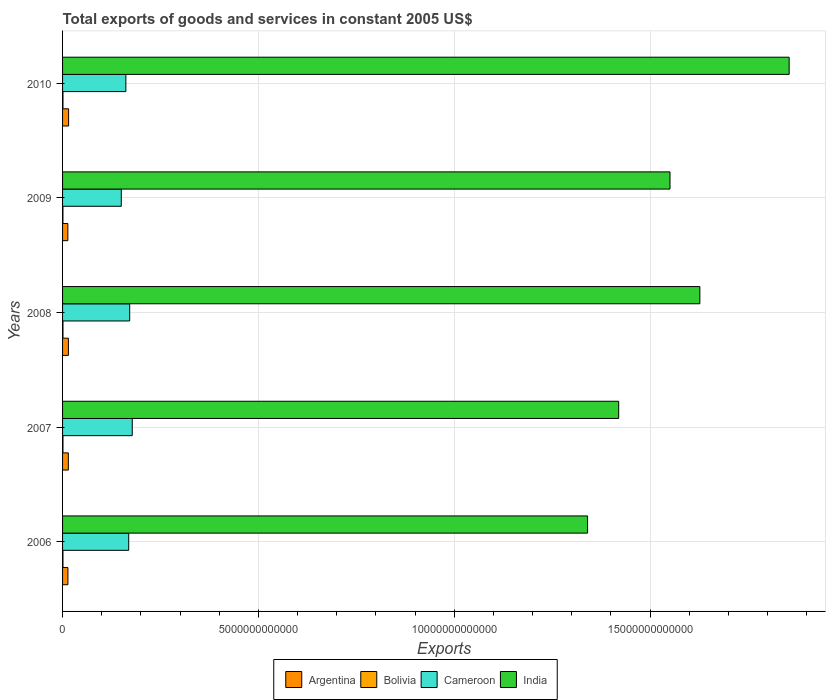How many different coloured bars are there?
Give a very brief answer. 4. How many groups of bars are there?
Offer a terse response. 5. Are the number of bars per tick equal to the number of legend labels?
Ensure brevity in your answer.  Yes. What is the label of the 5th group of bars from the top?
Ensure brevity in your answer.  2006. What is the total exports of goods and services in Bolivia in 2009?
Give a very brief answer. 9.33e+09. Across all years, what is the maximum total exports of goods and services in India?
Your answer should be very brief. 1.86e+13. Across all years, what is the minimum total exports of goods and services in Bolivia?
Make the answer very short. 9.33e+09. In which year was the total exports of goods and services in Cameroon maximum?
Ensure brevity in your answer.  2007. In which year was the total exports of goods and services in Argentina minimum?
Offer a terse response. 2009. What is the total total exports of goods and services in Argentina in the graph?
Your answer should be compact. 7.23e+11. What is the difference between the total exports of goods and services in Argentina in 2008 and that in 2009?
Your response must be concise. 1.40e+1. What is the difference between the total exports of goods and services in Argentina in 2006 and the total exports of goods and services in India in 2010?
Make the answer very short. -1.84e+13. What is the average total exports of goods and services in Cameroon per year?
Make the answer very short. 1.66e+12. In the year 2009, what is the difference between the total exports of goods and services in Bolivia and total exports of goods and services in Cameroon?
Your response must be concise. -1.49e+12. In how many years, is the total exports of goods and services in Bolivia greater than 6000000000000 US$?
Ensure brevity in your answer.  0. What is the ratio of the total exports of goods and services in Bolivia in 2006 to that in 2007?
Provide a short and direct response. 0.97. Is the total exports of goods and services in Argentina in 2007 less than that in 2008?
Your response must be concise. Yes. Is the difference between the total exports of goods and services in Bolivia in 2007 and 2010 greater than the difference between the total exports of goods and services in Cameroon in 2007 and 2010?
Offer a very short reply. No. What is the difference between the highest and the second highest total exports of goods and services in Argentina?
Provide a short and direct response. 4.93e+09. What is the difference between the highest and the lowest total exports of goods and services in India?
Keep it short and to the point. 5.15e+12. Is it the case that in every year, the sum of the total exports of goods and services in India and total exports of goods and services in Cameroon is greater than the sum of total exports of goods and services in Argentina and total exports of goods and services in Bolivia?
Offer a terse response. Yes. What does the 4th bar from the bottom in 2009 represents?
Keep it short and to the point. India. How many bars are there?
Offer a very short reply. 20. Are all the bars in the graph horizontal?
Ensure brevity in your answer.  Yes. What is the difference between two consecutive major ticks on the X-axis?
Your answer should be compact. 5.00e+12. Are the values on the major ticks of X-axis written in scientific E-notation?
Give a very brief answer. No. Does the graph contain any zero values?
Give a very brief answer. No. Does the graph contain grids?
Make the answer very short. Yes. Where does the legend appear in the graph?
Offer a very short reply. Bottom center. What is the title of the graph?
Your answer should be compact. Total exports of goods and services in constant 2005 US$. What is the label or title of the X-axis?
Your response must be concise. Exports. What is the Exports of Argentina in 2006?
Provide a succinct answer. 1.37e+11. What is the Exports of Bolivia in 2006?
Your answer should be compact. 9.92e+09. What is the Exports in Cameroon in 2006?
Offer a very short reply. 1.69e+12. What is the Exports of India in 2006?
Make the answer very short. 1.34e+13. What is the Exports in Argentina in 2007?
Offer a terse response. 1.48e+11. What is the Exports of Bolivia in 2007?
Make the answer very short. 1.02e+1. What is the Exports of Cameroon in 2007?
Keep it short and to the point. 1.78e+12. What is the Exports of India in 2007?
Provide a short and direct response. 1.42e+13. What is the Exports in Argentina in 2008?
Give a very brief answer. 1.49e+11. What is the Exports in Bolivia in 2008?
Provide a succinct answer. 1.05e+1. What is the Exports of Cameroon in 2008?
Your answer should be compact. 1.71e+12. What is the Exports of India in 2008?
Provide a succinct answer. 1.63e+13. What is the Exports of Argentina in 2009?
Make the answer very short. 1.35e+11. What is the Exports of Bolivia in 2009?
Ensure brevity in your answer.  9.33e+09. What is the Exports in Cameroon in 2009?
Keep it short and to the point. 1.50e+12. What is the Exports in India in 2009?
Provide a short and direct response. 1.55e+13. What is the Exports in Argentina in 2010?
Offer a very short reply. 1.54e+11. What is the Exports in Bolivia in 2010?
Keep it short and to the point. 1.02e+1. What is the Exports in Cameroon in 2010?
Your response must be concise. 1.62e+12. What is the Exports in India in 2010?
Give a very brief answer. 1.86e+13. Across all years, what is the maximum Exports of Argentina?
Make the answer very short. 1.54e+11. Across all years, what is the maximum Exports in Bolivia?
Keep it short and to the point. 1.05e+1. Across all years, what is the maximum Exports in Cameroon?
Offer a very short reply. 1.78e+12. Across all years, what is the maximum Exports of India?
Provide a short and direct response. 1.86e+13. Across all years, what is the minimum Exports of Argentina?
Make the answer very short. 1.35e+11. Across all years, what is the minimum Exports of Bolivia?
Make the answer very short. 9.33e+09. Across all years, what is the minimum Exports of Cameroon?
Keep it short and to the point. 1.50e+12. Across all years, what is the minimum Exports in India?
Provide a short and direct response. 1.34e+13. What is the total Exports of Argentina in the graph?
Offer a terse response. 7.23e+11. What is the total Exports of Bolivia in the graph?
Keep it short and to the point. 5.02e+1. What is the total Exports of Cameroon in the graph?
Provide a succinct answer. 8.30e+12. What is the total Exports of India in the graph?
Make the answer very short. 7.79e+13. What is the difference between the Exports in Argentina in 2006 and that in 2007?
Ensure brevity in your answer.  -1.08e+1. What is the difference between the Exports of Bolivia in 2006 and that in 2007?
Keep it short and to the point. -3.07e+08. What is the difference between the Exports of Cameroon in 2006 and that in 2007?
Provide a short and direct response. -9.02e+1. What is the difference between the Exports of India in 2006 and that in 2007?
Offer a very short reply. -7.94e+11. What is the difference between the Exports in Argentina in 2006 and that in 2008?
Offer a very short reply. -1.24e+1. What is the difference between the Exports of Bolivia in 2006 and that in 2008?
Provide a short and direct response. -5.29e+08. What is the difference between the Exports of Cameroon in 2006 and that in 2008?
Give a very brief answer. -2.45e+1. What is the difference between the Exports in India in 2006 and that in 2008?
Your response must be concise. -2.87e+12. What is the difference between the Exports in Argentina in 2006 and that in 2009?
Offer a terse response. 1.64e+09. What is the difference between the Exports of Bolivia in 2006 and that in 2009?
Your response must be concise. 5.95e+08. What is the difference between the Exports of Cameroon in 2006 and that in 2009?
Ensure brevity in your answer.  1.90e+11. What is the difference between the Exports of India in 2006 and that in 2009?
Offer a terse response. -2.10e+12. What is the difference between the Exports of Argentina in 2006 and that in 2010?
Make the answer very short. -1.73e+1. What is the difference between the Exports of Bolivia in 2006 and that in 2010?
Your answer should be very brief. -3.24e+08. What is the difference between the Exports of Cameroon in 2006 and that in 2010?
Your response must be concise. 7.30e+1. What is the difference between the Exports in India in 2006 and that in 2010?
Your answer should be compact. -5.15e+12. What is the difference between the Exports in Argentina in 2007 and that in 2008?
Make the answer very short. -1.61e+09. What is the difference between the Exports in Bolivia in 2007 and that in 2008?
Make the answer very short. -2.22e+08. What is the difference between the Exports of Cameroon in 2007 and that in 2008?
Ensure brevity in your answer.  6.56e+1. What is the difference between the Exports of India in 2007 and that in 2008?
Provide a short and direct response. -2.07e+12. What is the difference between the Exports of Argentina in 2007 and that in 2009?
Ensure brevity in your answer.  1.24e+1. What is the difference between the Exports of Bolivia in 2007 and that in 2009?
Give a very brief answer. 9.02e+08. What is the difference between the Exports of Cameroon in 2007 and that in 2009?
Your response must be concise. 2.80e+11. What is the difference between the Exports of India in 2007 and that in 2009?
Your response must be concise. -1.31e+12. What is the difference between the Exports in Argentina in 2007 and that in 2010?
Ensure brevity in your answer.  -6.54e+09. What is the difference between the Exports in Bolivia in 2007 and that in 2010?
Provide a succinct answer. -1.73e+07. What is the difference between the Exports of Cameroon in 2007 and that in 2010?
Ensure brevity in your answer.  1.63e+11. What is the difference between the Exports of India in 2007 and that in 2010?
Provide a short and direct response. -4.35e+12. What is the difference between the Exports of Argentina in 2008 and that in 2009?
Give a very brief answer. 1.40e+1. What is the difference between the Exports of Bolivia in 2008 and that in 2009?
Your answer should be compact. 1.12e+09. What is the difference between the Exports in Cameroon in 2008 and that in 2009?
Your answer should be compact. 2.14e+11. What is the difference between the Exports in India in 2008 and that in 2009?
Your answer should be very brief. 7.62e+11. What is the difference between the Exports of Argentina in 2008 and that in 2010?
Give a very brief answer. -4.93e+09. What is the difference between the Exports of Bolivia in 2008 and that in 2010?
Your answer should be compact. 2.05e+08. What is the difference between the Exports in Cameroon in 2008 and that in 2010?
Your response must be concise. 9.75e+1. What is the difference between the Exports in India in 2008 and that in 2010?
Your answer should be very brief. -2.28e+12. What is the difference between the Exports in Argentina in 2009 and that in 2010?
Provide a short and direct response. -1.89e+1. What is the difference between the Exports of Bolivia in 2009 and that in 2010?
Ensure brevity in your answer.  -9.19e+08. What is the difference between the Exports of Cameroon in 2009 and that in 2010?
Make the answer very short. -1.17e+11. What is the difference between the Exports of India in 2009 and that in 2010?
Give a very brief answer. -3.04e+12. What is the difference between the Exports of Argentina in 2006 and the Exports of Bolivia in 2007?
Your answer should be compact. 1.27e+11. What is the difference between the Exports in Argentina in 2006 and the Exports in Cameroon in 2007?
Provide a succinct answer. -1.64e+12. What is the difference between the Exports in Argentina in 2006 and the Exports in India in 2007?
Provide a short and direct response. -1.41e+13. What is the difference between the Exports of Bolivia in 2006 and the Exports of Cameroon in 2007?
Give a very brief answer. -1.77e+12. What is the difference between the Exports in Bolivia in 2006 and the Exports in India in 2007?
Give a very brief answer. -1.42e+13. What is the difference between the Exports of Cameroon in 2006 and the Exports of India in 2007?
Offer a very short reply. -1.25e+13. What is the difference between the Exports in Argentina in 2006 and the Exports in Bolivia in 2008?
Provide a short and direct response. 1.26e+11. What is the difference between the Exports in Argentina in 2006 and the Exports in Cameroon in 2008?
Offer a very short reply. -1.58e+12. What is the difference between the Exports in Argentina in 2006 and the Exports in India in 2008?
Offer a terse response. -1.61e+13. What is the difference between the Exports in Bolivia in 2006 and the Exports in Cameroon in 2008?
Ensure brevity in your answer.  -1.70e+12. What is the difference between the Exports of Bolivia in 2006 and the Exports of India in 2008?
Your response must be concise. -1.63e+13. What is the difference between the Exports in Cameroon in 2006 and the Exports in India in 2008?
Provide a succinct answer. -1.46e+13. What is the difference between the Exports in Argentina in 2006 and the Exports in Bolivia in 2009?
Ensure brevity in your answer.  1.27e+11. What is the difference between the Exports of Argentina in 2006 and the Exports of Cameroon in 2009?
Your answer should be compact. -1.36e+12. What is the difference between the Exports of Argentina in 2006 and the Exports of India in 2009?
Your answer should be very brief. -1.54e+13. What is the difference between the Exports in Bolivia in 2006 and the Exports in Cameroon in 2009?
Offer a very short reply. -1.49e+12. What is the difference between the Exports of Bolivia in 2006 and the Exports of India in 2009?
Offer a terse response. -1.55e+13. What is the difference between the Exports of Cameroon in 2006 and the Exports of India in 2009?
Make the answer very short. -1.38e+13. What is the difference between the Exports of Argentina in 2006 and the Exports of Bolivia in 2010?
Make the answer very short. 1.27e+11. What is the difference between the Exports in Argentina in 2006 and the Exports in Cameroon in 2010?
Keep it short and to the point. -1.48e+12. What is the difference between the Exports of Argentina in 2006 and the Exports of India in 2010?
Your answer should be very brief. -1.84e+13. What is the difference between the Exports in Bolivia in 2006 and the Exports in Cameroon in 2010?
Ensure brevity in your answer.  -1.61e+12. What is the difference between the Exports in Bolivia in 2006 and the Exports in India in 2010?
Provide a succinct answer. -1.85e+13. What is the difference between the Exports in Cameroon in 2006 and the Exports in India in 2010?
Keep it short and to the point. -1.69e+13. What is the difference between the Exports in Argentina in 2007 and the Exports in Bolivia in 2008?
Offer a very short reply. 1.37e+11. What is the difference between the Exports of Argentina in 2007 and the Exports of Cameroon in 2008?
Provide a short and direct response. -1.57e+12. What is the difference between the Exports of Argentina in 2007 and the Exports of India in 2008?
Make the answer very short. -1.61e+13. What is the difference between the Exports of Bolivia in 2007 and the Exports of Cameroon in 2008?
Ensure brevity in your answer.  -1.70e+12. What is the difference between the Exports of Bolivia in 2007 and the Exports of India in 2008?
Offer a very short reply. -1.63e+13. What is the difference between the Exports of Cameroon in 2007 and the Exports of India in 2008?
Keep it short and to the point. -1.45e+13. What is the difference between the Exports in Argentina in 2007 and the Exports in Bolivia in 2009?
Provide a succinct answer. 1.38e+11. What is the difference between the Exports of Argentina in 2007 and the Exports of Cameroon in 2009?
Ensure brevity in your answer.  -1.35e+12. What is the difference between the Exports in Argentina in 2007 and the Exports in India in 2009?
Your answer should be very brief. -1.54e+13. What is the difference between the Exports in Bolivia in 2007 and the Exports in Cameroon in 2009?
Your response must be concise. -1.49e+12. What is the difference between the Exports of Bolivia in 2007 and the Exports of India in 2009?
Ensure brevity in your answer.  -1.55e+13. What is the difference between the Exports in Cameroon in 2007 and the Exports in India in 2009?
Offer a terse response. -1.37e+13. What is the difference between the Exports in Argentina in 2007 and the Exports in Bolivia in 2010?
Your response must be concise. 1.37e+11. What is the difference between the Exports in Argentina in 2007 and the Exports in Cameroon in 2010?
Keep it short and to the point. -1.47e+12. What is the difference between the Exports of Argentina in 2007 and the Exports of India in 2010?
Your answer should be compact. -1.84e+13. What is the difference between the Exports of Bolivia in 2007 and the Exports of Cameroon in 2010?
Offer a very short reply. -1.61e+12. What is the difference between the Exports in Bolivia in 2007 and the Exports in India in 2010?
Your answer should be compact. -1.85e+13. What is the difference between the Exports in Cameroon in 2007 and the Exports in India in 2010?
Provide a succinct answer. -1.68e+13. What is the difference between the Exports of Argentina in 2008 and the Exports of Bolivia in 2009?
Make the answer very short. 1.40e+11. What is the difference between the Exports in Argentina in 2008 and the Exports in Cameroon in 2009?
Offer a very short reply. -1.35e+12. What is the difference between the Exports in Argentina in 2008 and the Exports in India in 2009?
Ensure brevity in your answer.  -1.54e+13. What is the difference between the Exports of Bolivia in 2008 and the Exports of Cameroon in 2009?
Your response must be concise. -1.49e+12. What is the difference between the Exports in Bolivia in 2008 and the Exports in India in 2009?
Provide a succinct answer. -1.55e+13. What is the difference between the Exports in Cameroon in 2008 and the Exports in India in 2009?
Your response must be concise. -1.38e+13. What is the difference between the Exports in Argentina in 2008 and the Exports in Bolivia in 2010?
Provide a short and direct response. 1.39e+11. What is the difference between the Exports in Argentina in 2008 and the Exports in Cameroon in 2010?
Your response must be concise. -1.47e+12. What is the difference between the Exports in Argentina in 2008 and the Exports in India in 2010?
Your answer should be very brief. -1.84e+13. What is the difference between the Exports in Bolivia in 2008 and the Exports in Cameroon in 2010?
Offer a very short reply. -1.61e+12. What is the difference between the Exports of Bolivia in 2008 and the Exports of India in 2010?
Offer a terse response. -1.85e+13. What is the difference between the Exports of Cameroon in 2008 and the Exports of India in 2010?
Ensure brevity in your answer.  -1.68e+13. What is the difference between the Exports in Argentina in 2009 and the Exports in Bolivia in 2010?
Keep it short and to the point. 1.25e+11. What is the difference between the Exports in Argentina in 2009 and the Exports in Cameroon in 2010?
Ensure brevity in your answer.  -1.48e+12. What is the difference between the Exports of Argentina in 2009 and the Exports of India in 2010?
Offer a terse response. -1.84e+13. What is the difference between the Exports in Bolivia in 2009 and the Exports in Cameroon in 2010?
Offer a very short reply. -1.61e+12. What is the difference between the Exports of Bolivia in 2009 and the Exports of India in 2010?
Give a very brief answer. -1.85e+13. What is the difference between the Exports of Cameroon in 2009 and the Exports of India in 2010?
Give a very brief answer. -1.71e+13. What is the average Exports of Argentina per year?
Provide a succinct answer. 1.45e+11. What is the average Exports in Bolivia per year?
Your answer should be very brief. 1.00e+1. What is the average Exports of Cameroon per year?
Keep it short and to the point. 1.66e+12. What is the average Exports in India per year?
Your answer should be compact. 1.56e+13. In the year 2006, what is the difference between the Exports of Argentina and Exports of Bolivia?
Your response must be concise. 1.27e+11. In the year 2006, what is the difference between the Exports in Argentina and Exports in Cameroon?
Ensure brevity in your answer.  -1.55e+12. In the year 2006, what is the difference between the Exports of Argentina and Exports of India?
Provide a short and direct response. -1.33e+13. In the year 2006, what is the difference between the Exports in Bolivia and Exports in Cameroon?
Your response must be concise. -1.68e+12. In the year 2006, what is the difference between the Exports of Bolivia and Exports of India?
Give a very brief answer. -1.34e+13. In the year 2006, what is the difference between the Exports of Cameroon and Exports of India?
Provide a short and direct response. -1.17e+13. In the year 2007, what is the difference between the Exports in Argentina and Exports in Bolivia?
Offer a very short reply. 1.37e+11. In the year 2007, what is the difference between the Exports of Argentina and Exports of Cameroon?
Your response must be concise. -1.63e+12. In the year 2007, what is the difference between the Exports in Argentina and Exports in India?
Keep it short and to the point. -1.41e+13. In the year 2007, what is the difference between the Exports of Bolivia and Exports of Cameroon?
Provide a succinct answer. -1.77e+12. In the year 2007, what is the difference between the Exports in Bolivia and Exports in India?
Make the answer very short. -1.42e+13. In the year 2007, what is the difference between the Exports in Cameroon and Exports in India?
Offer a terse response. -1.24e+13. In the year 2008, what is the difference between the Exports in Argentina and Exports in Bolivia?
Your response must be concise. 1.39e+11. In the year 2008, what is the difference between the Exports of Argentina and Exports of Cameroon?
Make the answer very short. -1.56e+12. In the year 2008, what is the difference between the Exports in Argentina and Exports in India?
Make the answer very short. -1.61e+13. In the year 2008, what is the difference between the Exports in Bolivia and Exports in Cameroon?
Ensure brevity in your answer.  -1.70e+12. In the year 2008, what is the difference between the Exports of Bolivia and Exports of India?
Keep it short and to the point. -1.63e+13. In the year 2008, what is the difference between the Exports in Cameroon and Exports in India?
Offer a very short reply. -1.46e+13. In the year 2009, what is the difference between the Exports of Argentina and Exports of Bolivia?
Offer a terse response. 1.26e+11. In the year 2009, what is the difference between the Exports in Argentina and Exports in Cameroon?
Offer a terse response. -1.36e+12. In the year 2009, what is the difference between the Exports of Argentina and Exports of India?
Provide a succinct answer. -1.54e+13. In the year 2009, what is the difference between the Exports of Bolivia and Exports of Cameroon?
Make the answer very short. -1.49e+12. In the year 2009, what is the difference between the Exports in Bolivia and Exports in India?
Offer a terse response. -1.55e+13. In the year 2009, what is the difference between the Exports in Cameroon and Exports in India?
Ensure brevity in your answer.  -1.40e+13. In the year 2010, what is the difference between the Exports of Argentina and Exports of Bolivia?
Provide a short and direct response. 1.44e+11. In the year 2010, what is the difference between the Exports of Argentina and Exports of Cameroon?
Provide a short and direct response. -1.46e+12. In the year 2010, what is the difference between the Exports of Argentina and Exports of India?
Give a very brief answer. -1.84e+13. In the year 2010, what is the difference between the Exports in Bolivia and Exports in Cameroon?
Ensure brevity in your answer.  -1.61e+12. In the year 2010, what is the difference between the Exports in Bolivia and Exports in India?
Your answer should be very brief. -1.85e+13. In the year 2010, what is the difference between the Exports of Cameroon and Exports of India?
Your answer should be compact. -1.69e+13. What is the ratio of the Exports of Argentina in 2006 to that in 2007?
Provide a succinct answer. 0.93. What is the ratio of the Exports of Cameroon in 2006 to that in 2007?
Offer a terse response. 0.95. What is the ratio of the Exports in India in 2006 to that in 2007?
Offer a very short reply. 0.94. What is the ratio of the Exports in Argentina in 2006 to that in 2008?
Keep it short and to the point. 0.92. What is the ratio of the Exports in Bolivia in 2006 to that in 2008?
Ensure brevity in your answer.  0.95. What is the ratio of the Exports in Cameroon in 2006 to that in 2008?
Provide a succinct answer. 0.99. What is the ratio of the Exports of India in 2006 to that in 2008?
Make the answer very short. 0.82. What is the ratio of the Exports of Argentina in 2006 to that in 2009?
Give a very brief answer. 1.01. What is the ratio of the Exports in Bolivia in 2006 to that in 2009?
Your response must be concise. 1.06. What is the ratio of the Exports of Cameroon in 2006 to that in 2009?
Provide a succinct answer. 1.13. What is the ratio of the Exports in India in 2006 to that in 2009?
Offer a very short reply. 0.86. What is the ratio of the Exports of Argentina in 2006 to that in 2010?
Keep it short and to the point. 0.89. What is the ratio of the Exports of Bolivia in 2006 to that in 2010?
Your response must be concise. 0.97. What is the ratio of the Exports in Cameroon in 2006 to that in 2010?
Keep it short and to the point. 1.05. What is the ratio of the Exports in India in 2006 to that in 2010?
Offer a terse response. 0.72. What is the ratio of the Exports in Bolivia in 2007 to that in 2008?
Make the answer very short. 0.98. What is the ratio of the Exports in Cameroon in 2007 to that in 2008?
Provide a succinct answer. 1.04. What is the ratio of the Exports of India in 2007 to that in 2008?
Offer a terse response. 0.87. What is the ratio of the Exports in Argentina in 2007 to that in 2009?
Your response must be concise. 1.09. What is the ratio of the Exports in Bolivia in 2007 to that in 2009?
Keep it short and to the point. 1.1. What is the ratio of the Exports of Cameroon in 2007 to that in 2009?
Make the answer very short. 1.19. What is the ratio of the Exports of India in 2007 to that in 2009?
Your response must be concise. 0.92. What is the ratio of the Exports in Argentina in 2007 to that in 2010?
Make the answer very short. 0.96. What is the ratio of the Exports of Bolivia in 2007 to that in 2010?
Your answer should be very brief. 1. What is the ratio of the Exports in Cameroon in 2007 to that in 2010?
Offer a terse response. 1.1. What is the ratio of the Exports of India in 2007 to that in 2010?
Ensure brevity in your answer.  0.77. What is the ratio of the Exports of Argentina in 2008 to that in 2009?
Ensure brevity in your answer.  1.1. What is the ratio of the Exports in Bolivia in 2008 to that in 2009?
Your response must be concise. 1.12. What is the ratio of the Exports of India in 2008 to that in 2009?
Offer a very short reply. 1.05. What is the ratio of the Exports in Cameroon in 2008 to that in 2010?
Your answer should be very brief. 1.06. What is the ratio of the Exports of India in 2008 to that in 2010?
Offer a terse response. 0.88. What is the ratio of the Exports of Argentina in 2009 to that in 2010?
Your response must be concise. 0.88. What is the ratio of the Exports of Bolivia in 2009 to that in 2010?
Provide a succinct answer. 0.91. What is the ratio of the Exports in Cameroon in 2009 to that in 2010?
Ensure brevity in your answer.  0.93. What is the ratio of the Exports in India in 2009 to that in 2010?
Provide a succinct answer. 0.84. What is the difference between the highest and the second highest Exports of Argentina?
Offer a terse response. 4.93e+09. What is the difference between the highest and the second highest Exports of Bolivia?
Offer a very short reply. 2.05e+08. What is the difference between the highest and the second highest Exports in Cameroon?
Offer a very short reply. 6.56e+1. What is the difference between the highest and the second highest Exports in India?
Ensure brevity in your answer.  2.28e+12. What is the difference between the highest and the lowest Exports of Argentina?
Provide a short and direct response. 1.89e+1. What is the difference between the highest and the lowest Exports in Bolivia?
Provide a short and direct response. 1.12e+09. What is the difference between the highest and the lowest Exports of Cameroon?
Provide a short and direct response. 2.80e+11. What is the difference between the highest and the lowest Exports in India?
Make the answer very short. 5.15e+12. 